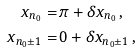<formula> <loc_0><loc_0><loc_500><loc_500>x _ { n _ { 0 } } = & \, \pi + \delta x _ { n _ { 0 } } \, , \\ x _ { n _ { 0 } \pm 1 } = & \, 0 + \delta x _ { n _ { 0 } \pm 1 } \, ,</formula> 